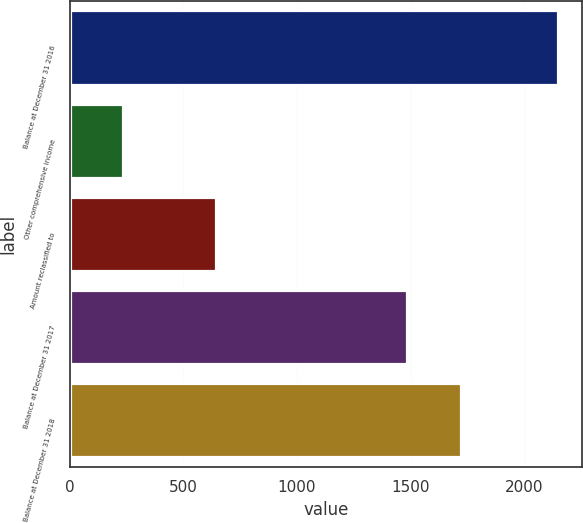Convert chart. <chart><loc_0><loc_0><loc_500><loc_500><bar_chart><fcel>Balance at December 31 2016<fcel>Other comprehensive income<fcel>Amount reclassified to<fcel>Balance at December 31 2017<fcel>Balance at December 31 2018<nl><fcel>2147<fcel>235<fcel>643<fcel>1486<fcel>1721<nl></chart> 